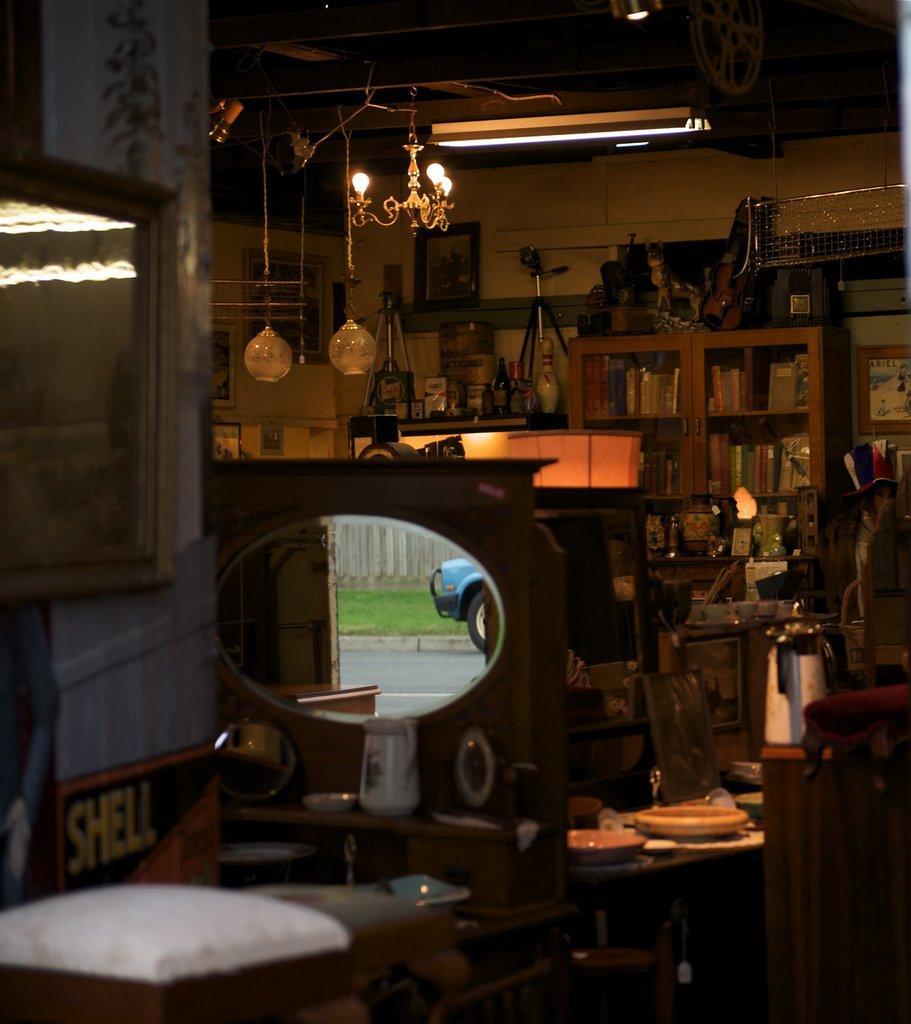How would you summarize this image in a sentence or two? This image is taken in a store where we can see mirrors, chairs, wall, lights, ceiling, bottles, tripod stands, frames, jar, table and a cupboard. 